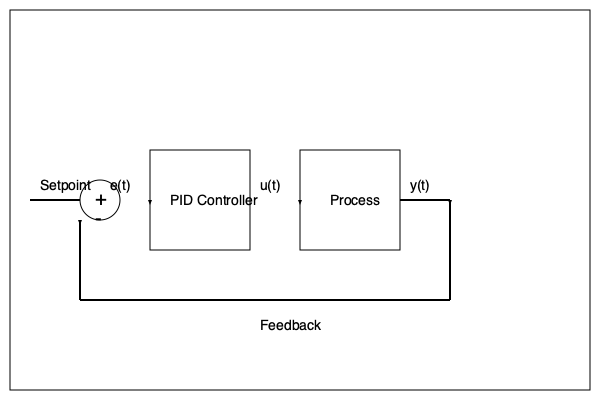In the PID control system block diagram shown above, what is the significance of the signal $e(t)$, and how does it relate to the overall control strategy? To understand the significance of $e(t)$ in the PID control system, let's break down the diagram and its components:

1. Setpoint: This is the desired value or target for the controlled variable.

2. Summing Junction: The circle with + and - signs represents a summing junction where the setpoint and the feedback signal are compared.

3. $e(t)$: This is the output of the summing junction, representing the error signal.

4. PID Controller: This block takes $e(t)$ as input and produces the control signal $u(t)$.

5. Process: This represents the system being controlled.

6. $y(t)$: This is the output of the process, which is fed back to the summing junction.

The significance of $e(t)$ lies in the following aspects:

1. Error Calculation: $e(t)$ is calculated as the difference between the setpoint and the measured output:

   $e(t) = \text{Setpoint} - y(t)$

2. Control Action Basis: The PID controller uses $e(t)$ to determine the appropriate control action. The controller output $u(t)$ is based on three terms:

   $u(t) = K_p e(t) + K_i \int_{0}^{t} e(\tau) d\tau + K_d \frac{de(t)}{dt}$

   Where $K_p$, $K_i$, and $K_d$ are the proportional, integral, and derivative gains, respectively.

3. Closed-loop Feedback: $e(t)$ enables the closed-loop feedback mechanism, allowing the system to continuously adjust its output to minimize the error.

4. Performance Indicator: The magnitude and behavior of $e(t)$ over time indicate how well the control system is performing in terms of tracking the setpoint and rejecting disturbances.

5. Stability Analysis: The characteristics of $e(t)$ (e.g., oscillations, steady-state value) can provide insights into the system's stability and dynamic response.

In summary, $e(t)$ is crucial for the PID control strategy as it quantifies the deviation from the desired setpoint, drives the control action, and serves as a key performance and stability indicator for the entire system.
Answer: $e(t)$ is the error signal, calculated as the difference between the setpoint and measured output, which drives the PID controller's actions to minimize deviations and maintain desired system performance. 